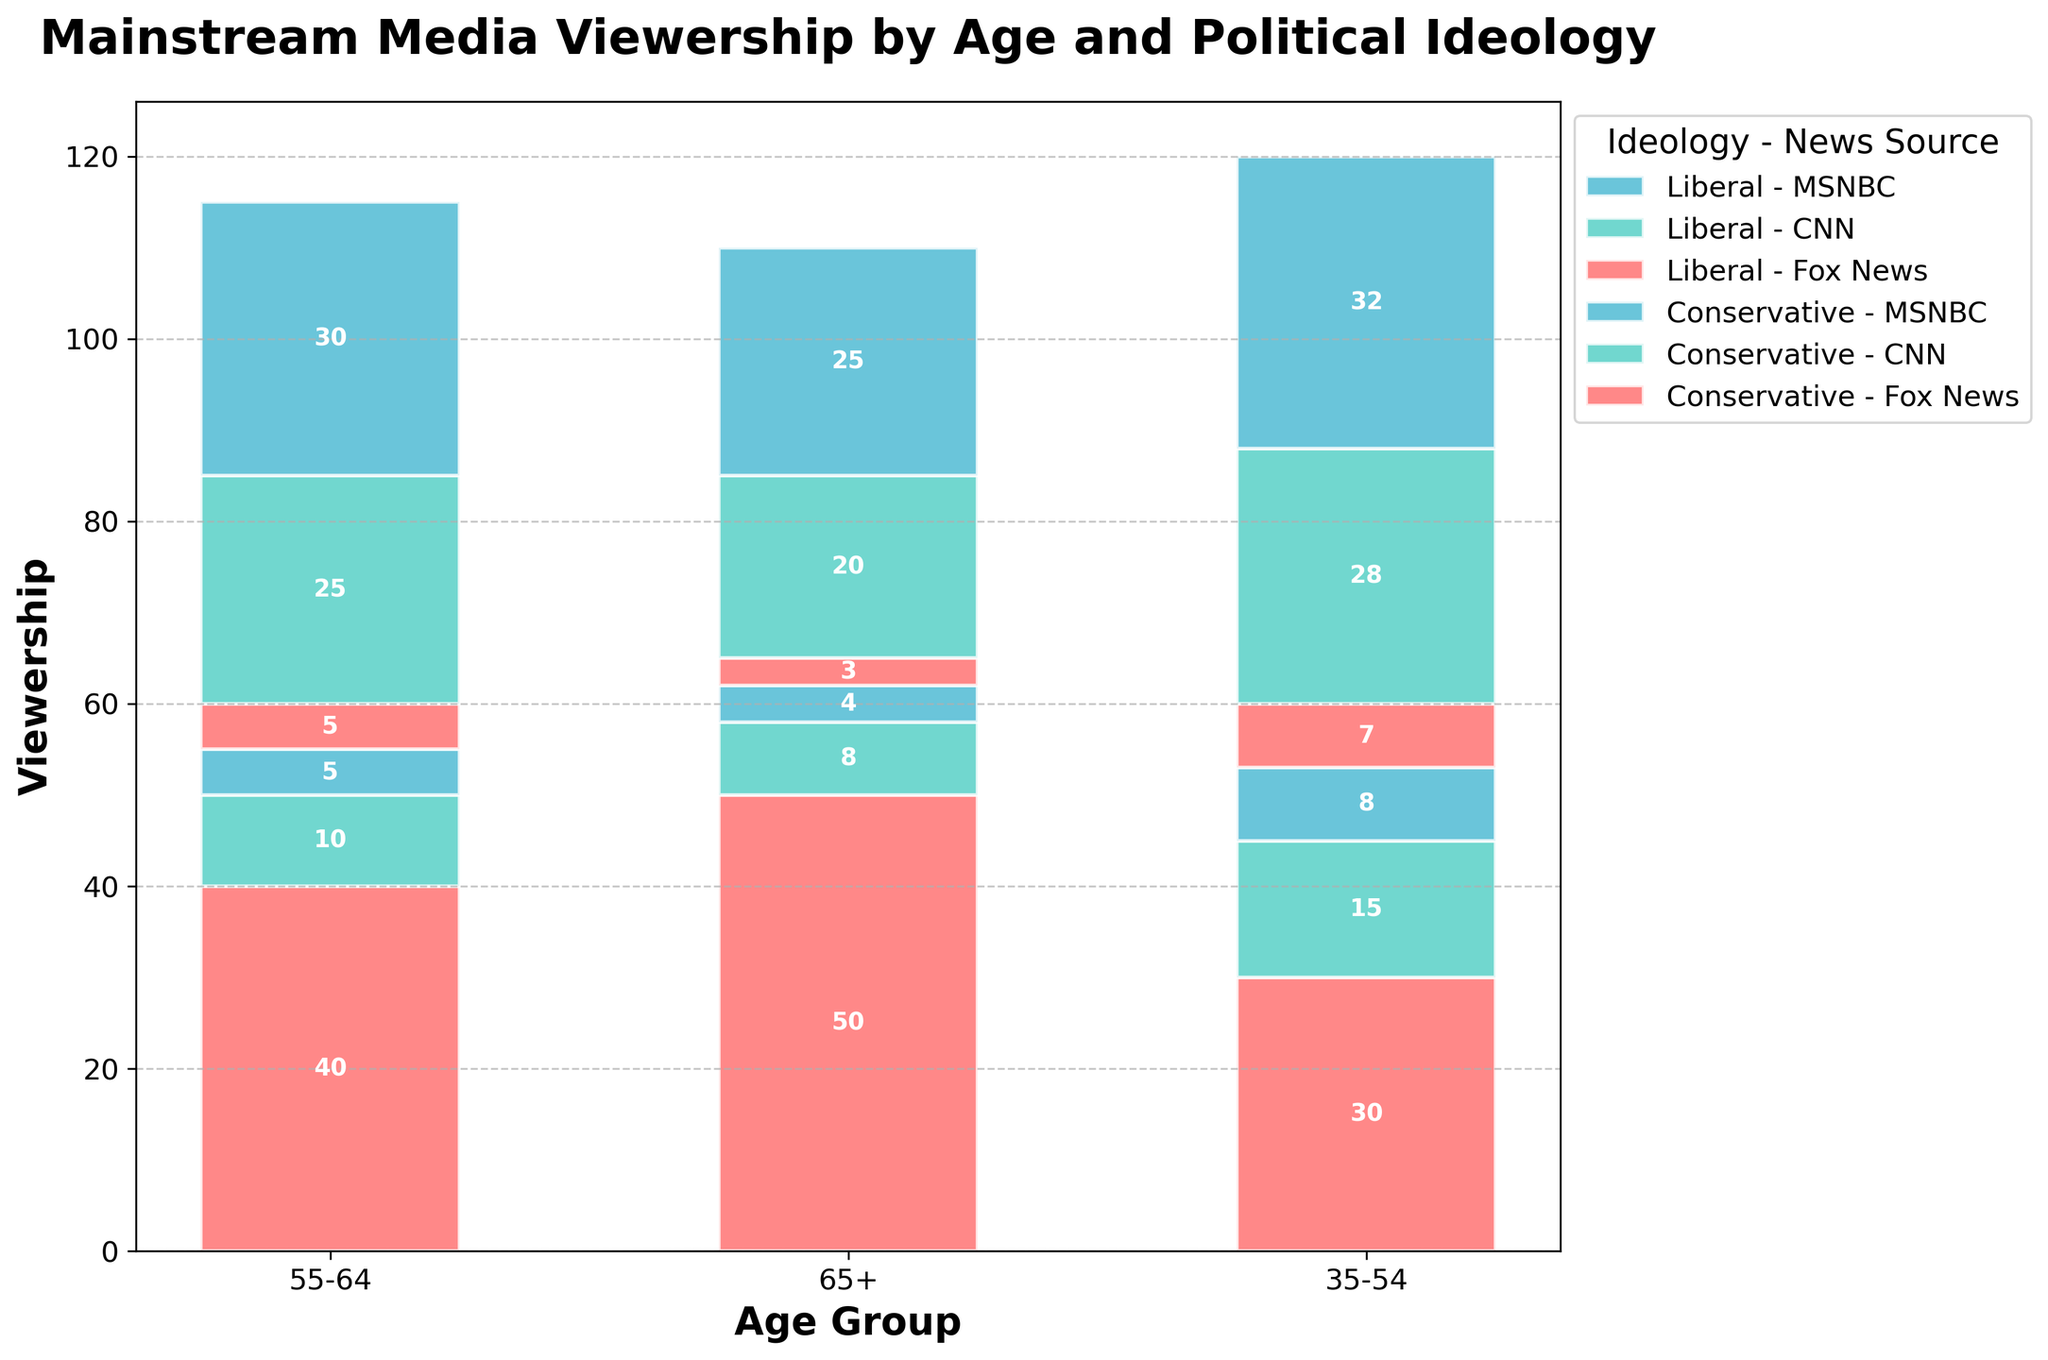Which age group has the highest Fox News viewership among conservatives? The tallest bar for Fox News in the conservative section indicates that age group 65+ has the highest viewership.
Answer: 65+ Which news source has the highest viewership among liberals aged 55-64? In the liberals section for the age group 55-64, the tallest bar is for MSNBC.
Answer: MSNBC What is the total viewership for CNN among conservatives across all age groups? Sum the heights of the CNN bars in the conservative section across age groups: 10 (55-64) + 8 (65+) + 15 (35-54) = 33.
Answer: 33 How does the Fox News viewership compare between the 65+ conservative group and the 65+ liberal group? The 65+ conservative group has a taller Fox News bar (50) compared to the 65+ liberal group (3).
Answer: 65+ conservatives have higher viewership What is the total viewership for MSNBC among all age groups combined? Sum the heights of the MSNBC bars across all age groups and political ideologies: 5 (55-64 Conservative) + 30 (55-64 Liberal) + 4 (65+ Conservative) + 25 (65+ Liberal) + 8 (35-54 Conservative) + 32 (35-54 Liberal) = 104.
Answer: 104 Which political ideology shows more diversity in news sources among the 35-54 age group? The liberal group has more even bars across different news sources compared to the conservative group, indicating more diversity.
Answer: Liberals Is there any age group where CNN viewership is higher than Fox News viewership within the same political ideology? In the age group 35-54 liberals, CNN (28) is higher than Fox News (7).
Answer: Yes, 35-54 liberals What is the difference in Fox News viewership between the 55-64 conservatives and the 35-54 conservatives? Subtract the Fox News viewership in the 35-54 conservatives from the 55-64 conservatives: 40 - 30 = 10.
Answer: 10 Which age group has the lowest MSNBC viewership among conservatives? The shortest MSNBC bar in the conservative section is in the age group 65+.
Answer: 65+ 